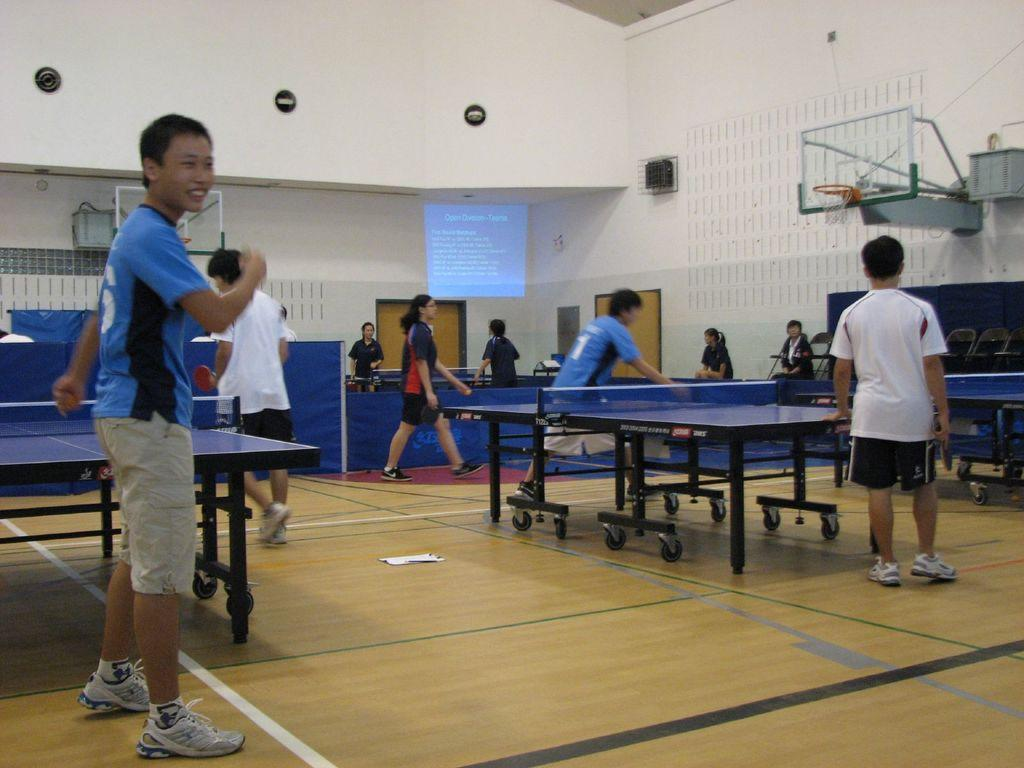What type of venue is depicted in the image? There is a stadium in the image. What sport or activity is being played in the stadium? People are playing table tennis in the stadium. Are there any spectators or other participants in the image? Yes, there are many people standing near the table tennis players, and they are also playing table tennis. Can you tell me how many grapes are on the table during the spy's secret meeting in the image? There is no spy or secret meeting present in the image, and therefore no grapes can be observed. 